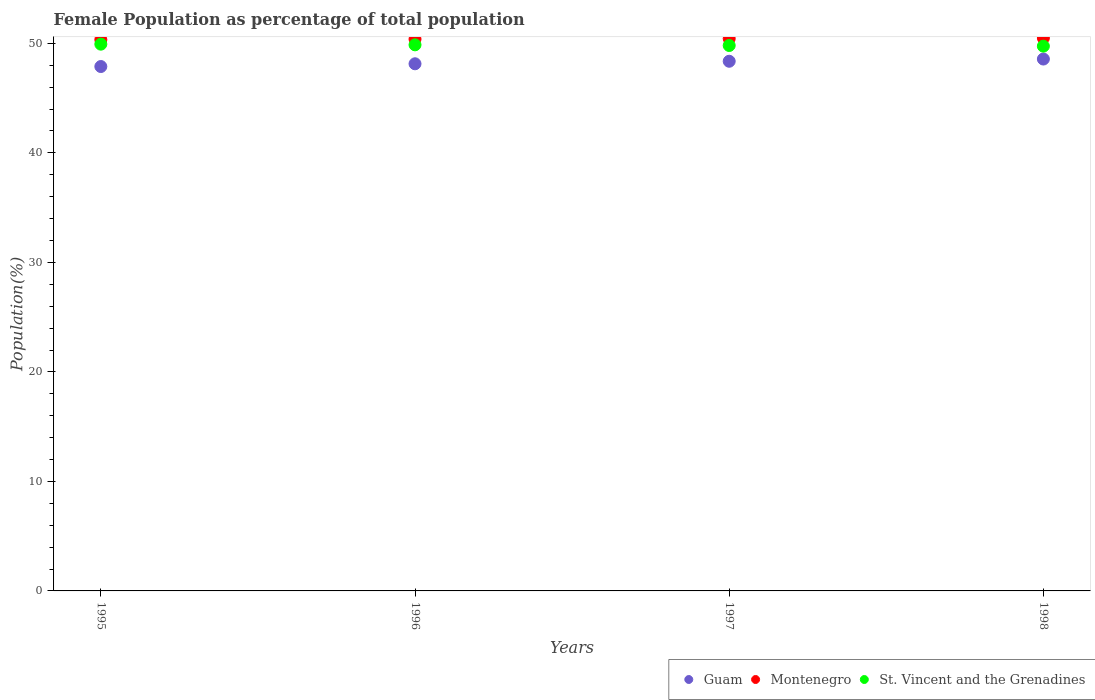What is the female population in in Montenegro in 1995?
Your response must be concise. 50.34. Across all years, what is the maximum female population in in Montenegro?
Give a very brief answer. 50.49. Across all years, what is the minimum female population in in Guam?
Provide a short and direct response. 47.89. In which year was the female population in in Montenegro maximum?
Your answer should be compact. 1998. In which year was the female population in in Guam minimum?
Your response must be concise. 1995. What is the total female population in in St. Vincent and the Grenadines in the graph?
Your answer should be very brief. 199.35. What is the difference between the female population in in Guam in 1995 and that in 1996?
Your answer should be compact. -0.25. What is the difference between the female population in in Guam in 1998 and the female population in in St. Vincent and the Grenadines in 1995?
Offer a terse response. -1.36. What is the average female population in in Guam per year?
Make the answer very short. 48.24. In the year 1997, what is the difference between the female population in in Guam and female population in in St. Vincent and the Grenadines?
Offer a terse response. -1.44. In how many years, is the female population in in Guam greater than 30 %?
Provide a succinct answer. 4. What is the ratio of the female population in in Guam in 1995 to that in 1996?
Your answer should be very brief. 0.99. Is the female population in in Montenegro in 1996 less than that in 1997?
Ensure brevity in your answer.  Yes. What is the difference between the highest and the second highest female population in in St. Vincent and the Grenadines?
Your response must be concise. 0.06. What is the difference between the highest and the lowest female population in in Guam?
Provide a succinct answer. 0.68. In how many years, is the female population in in St. Vincent and the Grenadines greater than the average female population in in St. Vincent and the Grenadines taken over all years?
Provide a succinct answer. 2. Is the sum of the female population in in Montenegro in 1996 and 1998 greater than the maximum female population in in Guam across all years?
Make the answer very short. Yes. Does the female population in in Montenegro monotonically increase over the years?
Ensure brevity in your answer.  Yes. Is the female population in in St. Vincent and the Grenadines strictly less than the female population in in Guam over the years?
Your response must be concise. No. How many dotlines are there?
Your answer should be compact. 3. Are the values on the major ticks of Y-axis written in scientific E-notation?
Your answer should be compact. No. Does the graph contain any zero values?
Offer a very short reply. No. How many legend labels are there?
Offer a terse response. 3. What is the title of the graph?
Give a very brief answer. Female Population as percentage of total population. What is the label or title of the Y-axis?
Offer a very short reply. Population(%). What is the Population(%) of Guam in 1995?
Offer a terse response. 47.89. What is the Population(%) of Montenegro in 1995?
Make the answer very short. 50.34. What is the Population(%) in St. Vincent and the Grenadines in 1995?
Your answer should be very brief. 49.93. What is the Population(%) in Guam in 1996?
Offer a terse response. 48.14. What is the Population(%) in Montenegro in 1996?
Provide a succinct answer. 50.39. What is the Population(%) in St. Vincent and the Grenadines in 1996?
Your response must be concise. 49.87. What is the Population(%) in Guam in 1997?
Ensure brevity in your answer.  48.37. What is the Population(%) of Montenegro in 1997?
Offer a terse response. 50.44. What is the Population(%) of St. Vincent and the Grenadines in 1997?
Offer a very short reply. 49.81. What is the Population(%) of Guam in 1998?
Provide a succinct answer. 48.57. What is the Population(%) in Montenegro in 1998?
Provide a short and direct response. 50.49. What is the Population(%) of St. Vincent and the Grenadines in 1998?
Make the answer very short. 49.75. Across all years, what is the maximum Population(%) in Guam?
Make the answer very short. 48.57. Across all years, what is the maximum Population(%) of Montenegro?
Offer a terse response. 50.49. Across all years, what is the maximum Population(%) in St. Vincent and the Grenadines?
Your response must be concise. 49.93. Across all years, what is the minimum Population(%) in Guam?
Your answer should be very brief. 47.89. Across all years, what is the minimum Population(%) of Montenegro?
Your answer should be very brief. 50.34. Across all years, what is the minimum Population(%) in St. Vincent and the Grenadines?
Offer a terse response. 49.75. What is the total Population(%) of Guam in the graph?
Give a very brief answer. 192.96. What is the total Population(%) of Montenegro in the graph?
Offer a very short reply. 201.67. What is the total Population(%) in St. Vincent and the Grenadines in the graph?
Provide a succinct answer. 199.35. What is the difference between the Population(%) in Guam in 1995 and that in 1996?
Ensure brevity in your answer.  -0.25. What is the difference between the Population(%) in Montenegro in 1995 and that in 1996?
Keep it short and to the point. -0.05. What is the difference between the Population(%) in St. Vincent and the Grenadines in 1995 and that in 1996?
Offer a very short reply. 0.06. What is the difference between the Population(%) of Guam in 1995 and that in 1997?
Offer a very short reply. -0.48. What is the difference between the Population(%) of Montenegro in 1995 and that in 1997?
Make the answer very short. -0.1. What is the difference between the Population(%) of St. Vincent and the Grenadines in 1995 and that in 1997?
Keep it short and to the point. 0.12. What is the difference between the Population(%) of Guam in 1995 and that in 1998?
Your response must be concise. -0.68. What is the difference between the Population(%) of Montenegro in 1995 and that in 1998?
Offer a terse response. -0.15. What is the difference between the Population(%) in St. Vincent and the Grenadines in 1995 and that in 1998?
Provide a succinct answer. 0.18. What is the difference between the Population(%) in Guam in 1996 and that in 1997?
Your answer should be very brief. -0.23. What is the difference between the Population(%) of Montenegro in 1996 and that in 1997?
Your response must be concise. -0.05. What is the difference between the Population(%) in St. Vincent and the Grenadines in 1996 and that in 1997?
Offer a very short reply. 0.06. What is the difference between the Population(%) of Guam in 1996 and that in 1998?
Keep it short and to the point. -0.43. What is the difference between the Population(%) of Montenegro in 1996 and that in 1998?
Offer a very short reply. -0.1. What is the difference between the Population(%) of St. Vincent and the Grenadines in 1996 and that in 1998?
Provide a short and direct response. 0.12. What is the difference between the Population(%) in Guam in 1997 and that in 1998?
Offer a terse response. -0.2. What is the difference between the Population(%) in Montenegro in 1997 and that in 1998?
Your response must be concise. -0.05. What is the difference between the Population(%) of St. Vincent and the Grenadines in 1997 and that in 1998?
Provide a succinct answer. 0.06. What is the difference between the Population(%) of Guam in 1995 and the Population(%) of Montenegro in 1996?
Your answer should be compact. -2.5. What is the difference between the Population(%) in Guam in 1995 and the Population(%) in St. Vincent and the Grenadines in 1996?
Offer a terse response. -1.98. What is the difference between the Population(%) of Montenegro in 1995 and the Population(%) of St. Vincent and the Grenadines in 1996?
Your answer should be compact. 0.47. What is the difference between the Population(%) of Guam in 1995 and the Population(%) of Montenegro in 1997?
Make the answer very short. -2.55. What is the difference between the Population(%) of Guam in 1995 and the Population(%) of St. Vincent and the Grenadines in 1997?
Provide a short and direct response. -1.92. What is the difference between the Population(%) of Montenegro in 1995 and the Population(%) of St. Vincent and the Grenadines in 1997?
Offer a very short reply. 0.53. What is the difference between the Population(%) of Guam in 1995 and the Population(%) of Montenegro in 1998?
Keep it short and to the point. -2.6. What is the difference between the Population(%) of Guam in 1995 and the Population(%) of St. Vincent and the Grenadines in 1998?
Keep it short and to the point. -1.86. What is the difference between the Population(%) of Montenegro in 1995 and the Population(%) of St. Vincent and the Grenadines in 1998?
Make the answer very short. 0.59. What is the difference between the Population(%) of Guam in 1996 and the Population(%) of Montenegro in 1997?
Your answer should be compact. -2.3. What is the difference between the Population(%) of Guam in 1996 and the Population(%) of St. Vincent and the Grenadines in 1997?
Offer a terse response. -1.67. What is the difference between the Population(%) of Montenegro in 1996 and the Population(%) of St. Vincent and the Grenadines in 1997?
Make the answer very short. 0.58. What is the difference between the Population(%) in Guam in 1996 and the Population(%) in Montenegro in 1998?
Give a very brief answer. -2.35. What is the difference between the Population(%) of Guam in 1996 and the Population(%) of St. Vincent and the Grenadines in 1998?
Provide a short and direct response. -1.61. What is the difference between the Population(%) in Montenegro in 1996 and the Population(%) in St. Vincent and the Grenadines in 1998?
Provide a succinct answer. 0.64. What is the difference between the Population(%) in Guam in 1997 and the Population(%) in Montenegro in 1998?
Provide a succinct answer. -2.12. What is the difference between the Population(%) of Guam in 1997 and the Population(%) of St. Vincent and the Grenadines in 1998?
Ensure brevity in your answer.  -1.38. What is the difference between the Population(%) in Montenegro in 1997 and the Population(%) in St. Vincent and the Grenadines in 1998?
Give a very brief answer. 0.69. What is the average Population(%) of Guam per year?
Your answer should be compact. 48.24. What is the average Population(%) of Montenegro per year?
Provide a succinct answer. 50.42. What is the average Population(%) in St. Vincent and the Grenadines per year?
Your answer should be compact. 49.84. In the year 1995, what is the difference between the Population(%) in Guam and Population(%) in Montenegro?
Ensure brevity in your answer.  -2.45. In the year 1995, what is the difference between the Population(%) of Guam and Population(%) of St. Vincent and the Grenadines?
Keep it short and to the point. -2.04. In the year 1995, what is the difference between the Population(%) in Montenegro and Population(%) in St. Vincent and the Grenadines?
Keep it short and to the point. 0.41. In the year 1996, what is the difference between the Population(%) of Guam and Population(%) of Montenegro?
Give a very brief answer. -2.25. In the year 1996, what is the difference between the Population(%) in Guam and Population(%) in St. Vincent and the Grenadines?
Keep it short and to the point. -1.73. In the year 1996, what is the difference between the Population(%) of Montenegro and Population(%) of St. Vincent and the Grenadines?
Provide a short and direct response. 0.52. In the year 1997, what is the difference between the Population(%) of Guam and Population(%) of Montenegro?
Offer a very short reply. -2.07. In the year 1997, what is the difference between the Population(%) in Guam and Population(%) in St. Vincent and the Grenadines?
Your answer should be compact. -1.44. In the year 1997, what is the difference between the Population(%) in Montenegro and Population(%) in St. Vincent and the Grenadines?
Provide a succinct answer. 0.63. In the year 1998, what is the difference between the Population(%) in Guam and Population(%) in Montenegro?
Make the answer very short. -1.92. In the year 1998, what is the difference between the Population(%) in Guam and Population(%) in St. Vincent and the Grenadines?
Provide a short and direct response. -1.18. In the year 1998, what is the difference between the Population(%) in Montenegro and Population(%) in St. Vincent and the Grenadines?
Give a very brief answer. 0.74. What is the ratio of the Population(%) of Guam in 1995 to that in 1996?
Make the answer very short. 0.99. What is the ratio of the Population(%) of Montenegro in 1995 to that in 1996?
Make the answer very short. 1. What is the ratio of the Population(%) in St. Vincent and the Grenadines in 1995 to that in 1996?
Provide a short and direct response. 1. What is the ratio of the Population(%) of Montenegro in 1995 to that in 1997?
Offer a terse response. 1. What is the ratio of the Population(%) in Guam in 1995 to that in 1998?
Give a very brief answer. 0.99. What is the ratio of the Population(%) of Montenegro in 1996 to that in 1997?
Keep it short and to the point. 1. What is the ratio of the Population(%) in Montenegro in 1996 to that in 1998?
Provide a short and direct response. 1. What is the ratio of the Population(%) of St. Vincent and the Grenadines in 1996 to that in 1998?
Offer a terse response. 1. What is the ratio of the Population(%) of Guam in 1997 to that in 1998?
Your answer should be compact. 1. What is the ratio of the Population(%) of Montenegro in 1997 to that in 1998?
Offer a very short reply. 1. What is the ratio of the Population(%) in St. Vincent and the Grenadines in 1997 to that in 1998?
Keep it short and to the point. 1. What is the difference between the highest and the second highest Population(%) in Guam?
Ensure brevity in your answer.  0.2. What is the difference between the highest and the second highest Population(%) in Montenegro?
Keep it short and to the point. 0.05. What is the difference between the highest and the second highest Population(%) of St. Vincent and the Grenadines?
Make the answer very short. 0.06. What is the difference between the highest and the lowest Population(%) in Guam?
Give a very brief answer. 0.68. What is the difference between the highest and the lowest Population(%) in Montenegro?
Your answer should be compact. 0.15. What is the difference between the highest and the lowest Population(%) in St. Vincent and the Grenadines?
Provide a short and direct response. 0.18. 